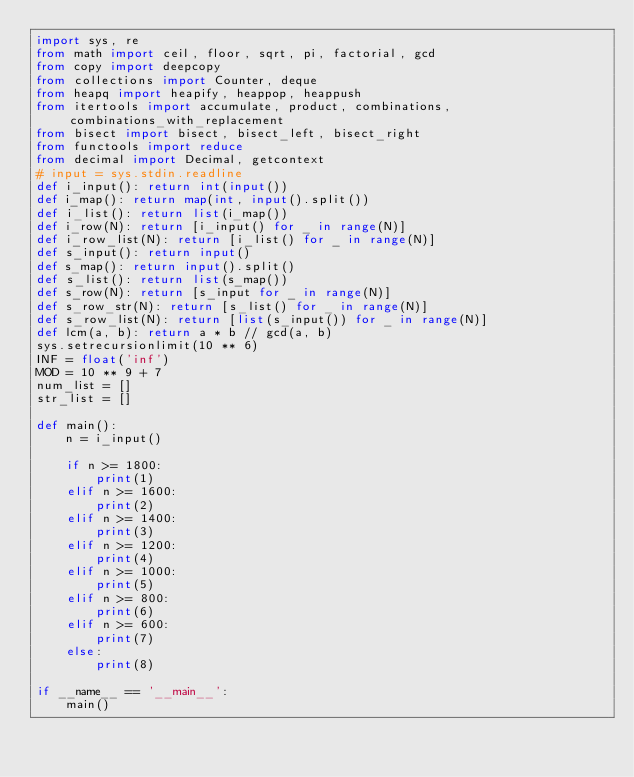Convert code to text. <code><loc_0><loc_0><loc_500><loc_500><_Python_>import sys, re
from math import ceil, floor, sqrt, pi, factorial, gcd
from copy import deepcopy
from collections import Counter, deque
from heapq import heapify, heappop, heappush
from itertools import accumulate, product, combinations, combinations_with_replacement
from bisect import bisect, bisect_left, bisect_right
from functools import reduce
from decimal import Decimal, getcontext
# input = sys.stdin.readline 
def i_input(): return int(input())
def i_map(): return map(int, input().split())
def i_list(): return list(i_map())
def i_row(N): return [i_input() for _ in range(N)]
def i_row_list(N): return [i_list() for _ in range(N)]
def s_input(): return input()
def s_map(): return input().split()
def s_list(): return list(s_map())
def s_row(N): return [s_input for _ in range(N)]
def s_row_str(N): return [s_list() for _ in range(N)]
def s_row_list(N): return [list(s_input()) for _ in range(N)]
def lcm(a, b): return a * b // gcd(a, b)
sys.setrecursionlimit(10 ** 6)
INF = float('inf')
MOD = 10 ** 9 + 7
num_list = []
str_list = []

def main():
    n = i_input()

    if n >= 1800:
        print(1)
    elif n >= 1600:
        print(2)
    elif n >= 1400:
        print(3)
    elif n >= 1200:
        print(4)
    elif n >= 1000:
        print(5)
    elif n >= 800:
        print(6)
    elif n >= 600:
        print(7)
    else:
        print(8)

if __name__ == '__main__':
    main()
</code> 